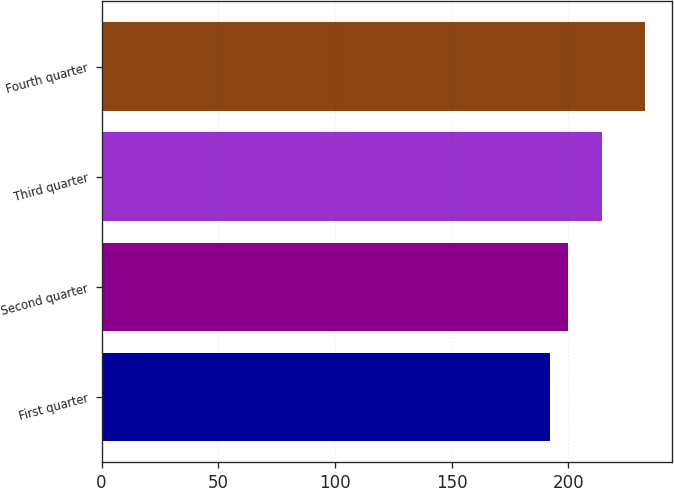Convert chart to OTSL. <chart><loc_0><loc_0><loc_500><loc_500><bar_chart><fcel>First quarter<fcel>Second quarter<fcel>Third quarter<fcel>Fourth quarter<nl><fcel>192.03<fcel>200<fcel>214.37<fcel>232.69<nl></chart> 